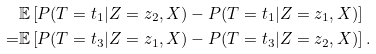Convert formula to latex. <formula><loc_0><loc_0><loc_500><loc_500>& \mathbb { E } \left [ P ( T = t _ { 1 } | Z = z _ { 2 } , X ) - P ( T = t _ { 1 } | Z = z _ { 1 } , X ) \right ] \\ = & \mathbb { E } \left [ P ( T = t _ { 3 } | Z = z _ { 1 } , X ) - P ( T = t _ { 3 } | Z = z _ { 2 } , X ) \right ] .</formula> 